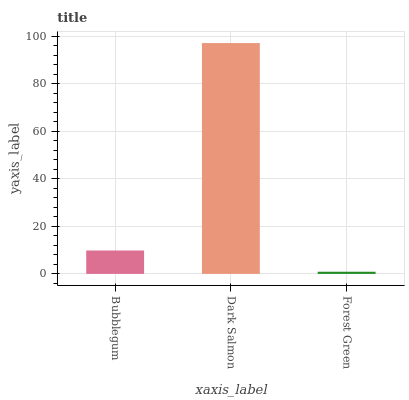Is Forest Green the minimum?
Answer yes or no. Yes. Is Dark Salmon the maximum?
Answer yes or no. Yes. Is Dark Salmon the minimum?
Answer yes or no. No. Is Forest Green the maximum?
Answer yes or no. No. Is Dark Salmon greater than Forest Green?
Answer yes or no. Yes. Is Forest Green less than Dark Salmon?
Answer yes or no. Yes. Is Forest Green greater than Dark Salmon?
Answer yes or no. No. Is Dark Salmon less than Forest Green?
Answer yes or no. No. Is Bubblegum the high median?
Answer yes or no. Yes. Is Bubblegum the low median?
Answer yes or no. Yes. Is Forest Green the high median?
Answer yes or no. No. Is Dark Salmon the low median?
Answer yes or no. No. 